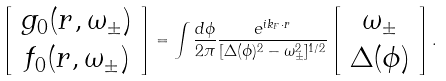<formula> <loc_0><loc_0><loc_500><loc_500>\left [ \begin{array} { c } g _ { 0 } ( { r } , \omega _ { \pm } ) \\ f _ { 0 } ( { r } , \omega _ { \pm } ) \end{array} \right ] = \int \frac { d \phi } { 2 \pi } \frac { e ^ { i { k } _ { F } \cdot { r } } } { [ \Delta ( \phi ) ^ { 2 } - \omega _ { \pm } ^ { 2 } ] ^ { 1 / 2 } } \left [ \begin{array} { c } \omega _ { \pm } \\ \Delta ( \phi ) \end{array} \right ] .</formula> 